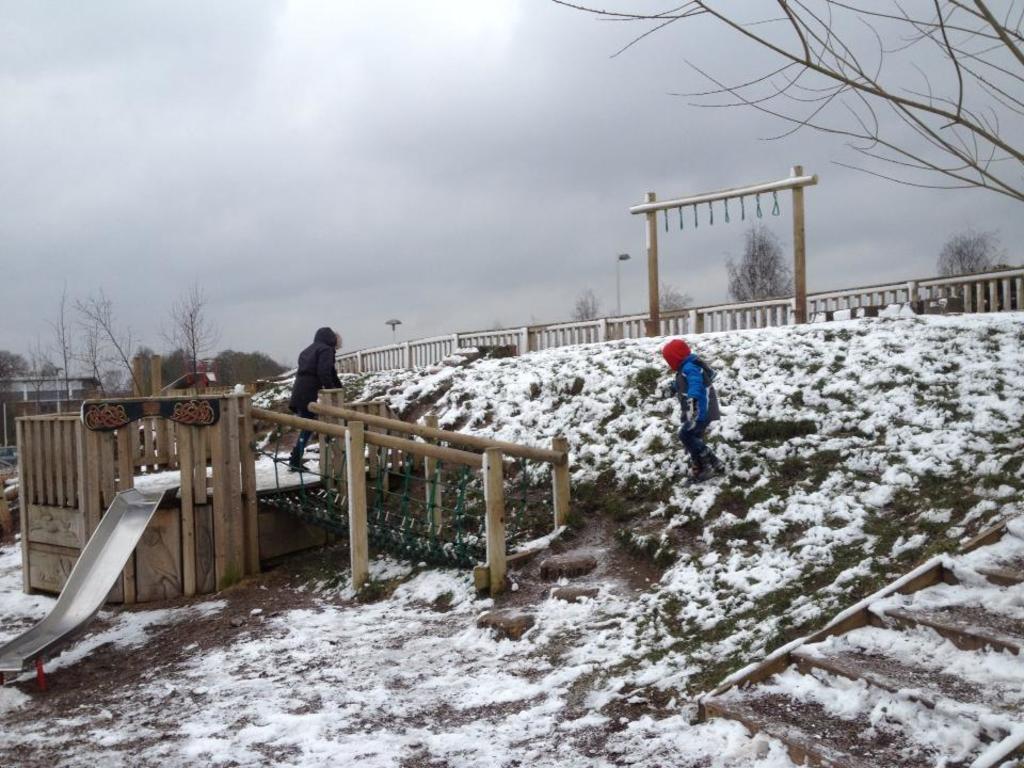How would you summarize this image in a sentence or two? In this picture we can observe two members. There is some snow on the ground. We can observe wooden railing here. There are some trees. In the background there is a sky with clouds. 